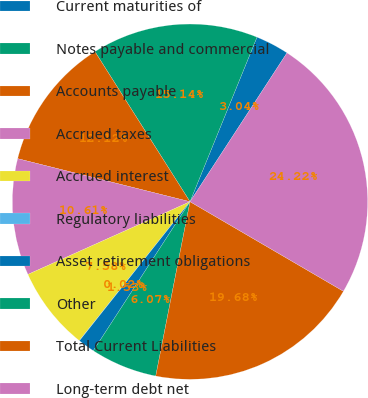<chart> <loc_0><loc_0><loc_500><loc_500><pie_chart><fcel>Current maturities of<fcel>Notes payable and commercial<fcel>Accounts payable<fcel>Accrued taxes<fcel>Accrued interest<fcel>Regulatory liabilities<fcel>Asset retirement obligations<fcel>Other<fcel>Total Current Liabilities<fcel>Long-term debt net<nl><fcel>3.04%<fcel>15.14%<fcel>12.12%<fcel>10.61%<fcel>7.58%<fcel>0.02%<fcel>1.53%<fcel>6.07%<fcel>19.68%<fcel>24.22%<nl></chart> 